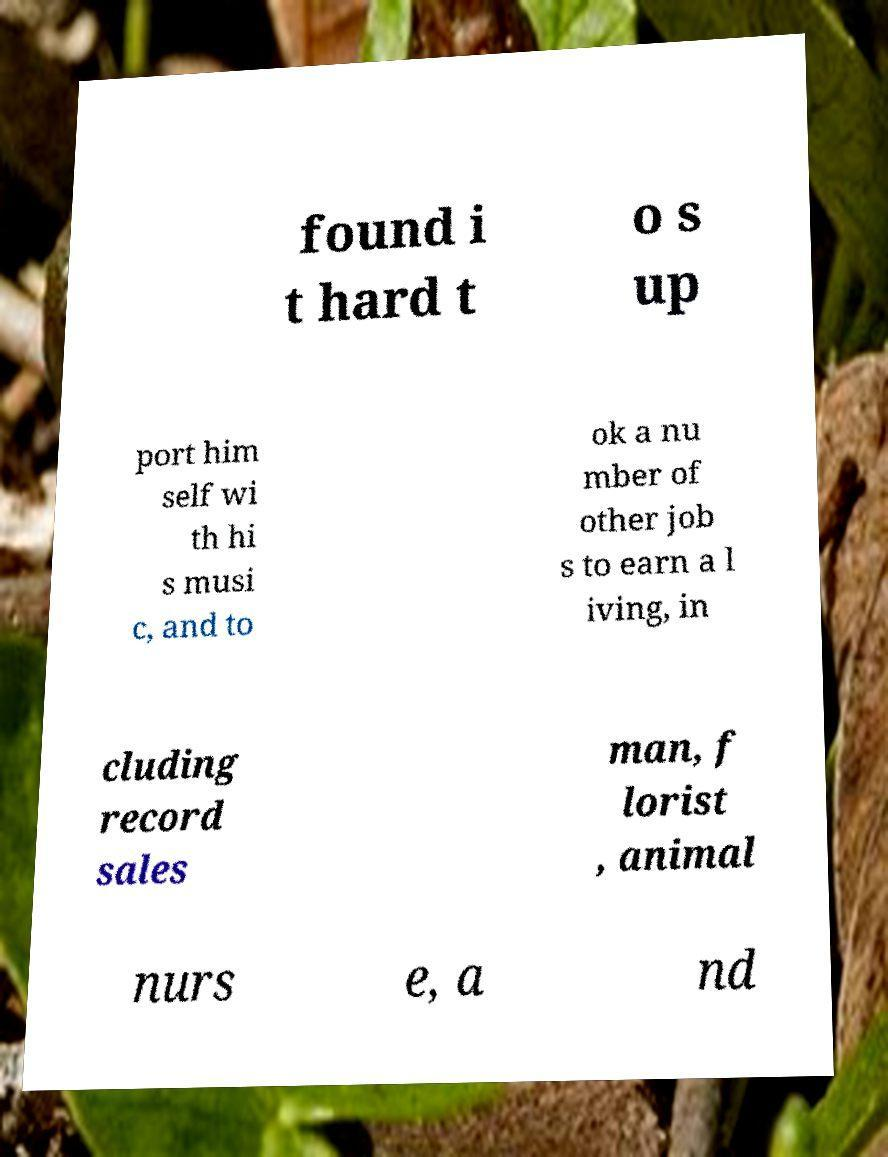Can you read and provide the text displayed in the image?This photo seems to have some interesting text. Can you extract and type it out for me? found i t hard t o s up port him self wi th hi s musi c, and to ok a nu mber of other job s to earn a l iving, in cluding record sales man, f lorist , animal nurs e, a nd 